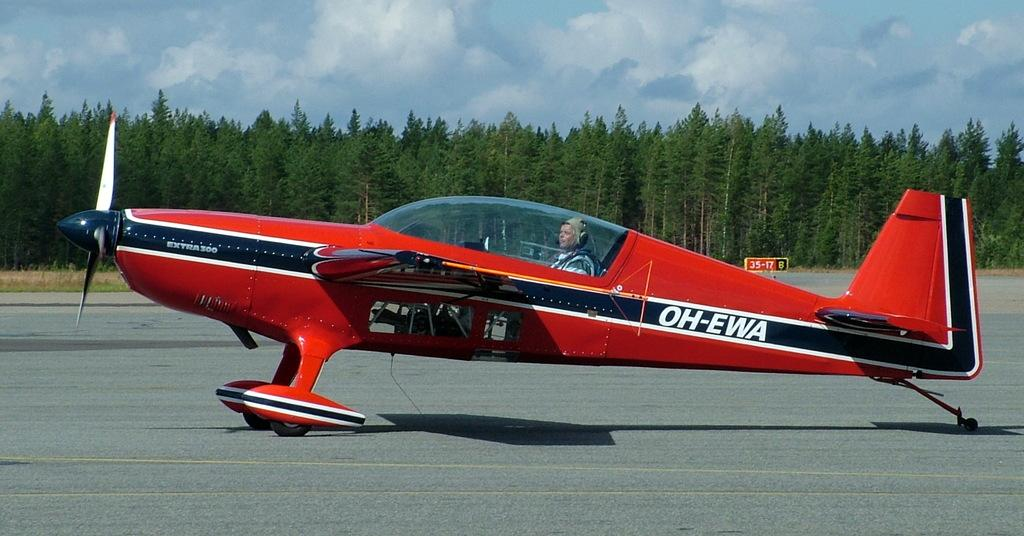<image>
Describe the image concisely. A red air plane is sitting on the runway with a tail number that says OH-EWA. 